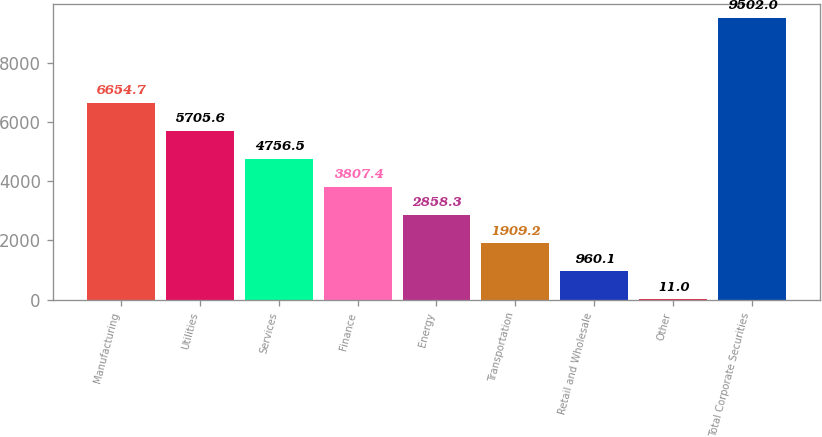Convert chart to OTSL. <chart><loc_0><loc_0><loc_500><loc_500><bar_chart><fcel>Manufacturing<fcel>Utilities<fcel>Services<fcel>Finance<fcel>Energy<fcel>Transportation<fcel>Retail and Wholesale<fcel>Other<fcel>Total Corporate Securities<nl><fcel>6654.7<fcel>5705.6<fcel>4756.5<fcel>3807.4<fcel>2858.3<fcel>1909.2<fcel>960.1<fcel>11<fcel>9502<nl></chart> 